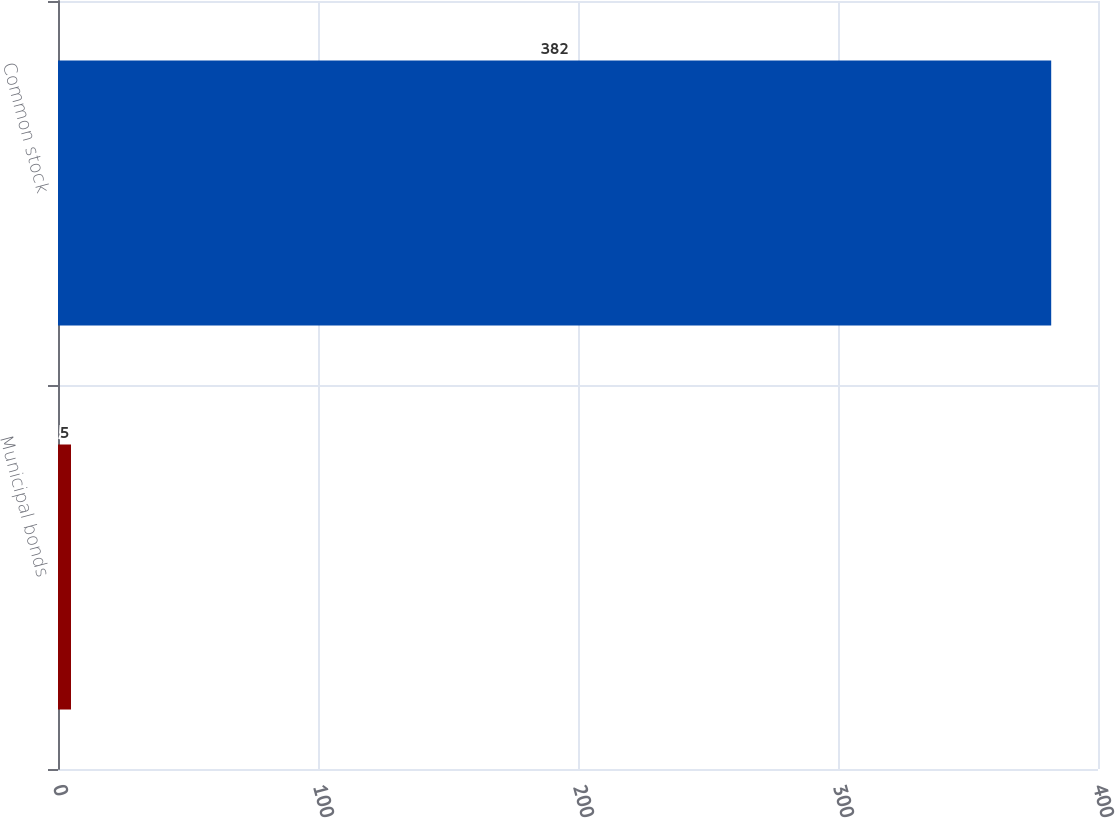Convert chart to OTSL. <chart><loc_0><loc_0><loc_500><loc_500><bar_chart><fcel>Municipal bonds<fcel>Common stock<nl><fcel>5<fcel>382<nl></chart> 